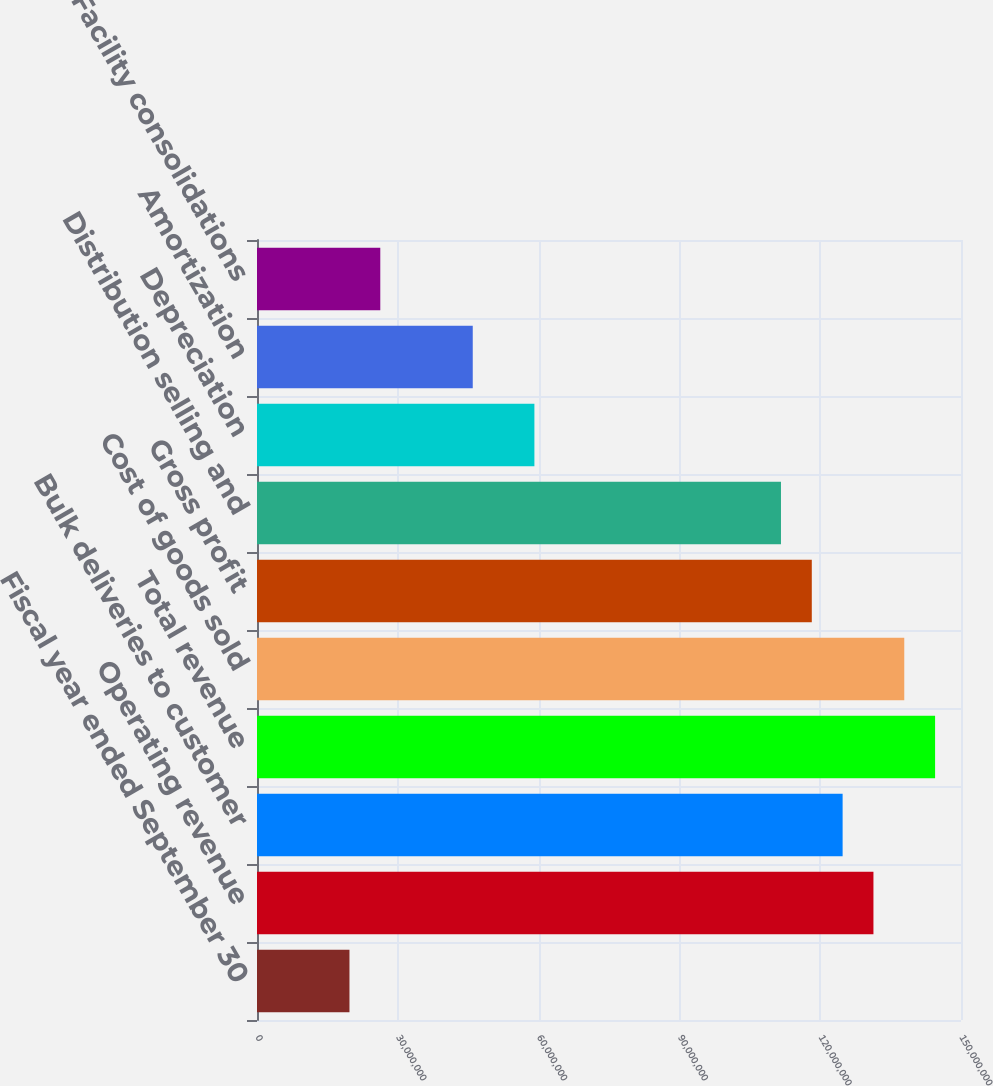<chart> <loc_0><loc_0><loc_500><loc_500><bar_chart><fcel>Fiscal year ended September 30<fcel>Operating revenue<fcel>Bulk deliveries to customer<fcel>Total revenue<fcel>Cost of goods sold<fcel>Gross profit<fcel>Distribution selling and<fcel>Depreciation<fcel>Amortization<fcel>Facility consolidations<nl><fcel>1.97016e+07<fcel>1.31344e+08<fcel>1.24777e+08<fcel>1.44479e+08<fcel>1.37911e+08<fcel>1.1821e+08<fcel>1.11643e+08<fcel>5.91049e+07<fcel>4.59705e+07<fcel>2.62688e+07<nl></chart> 